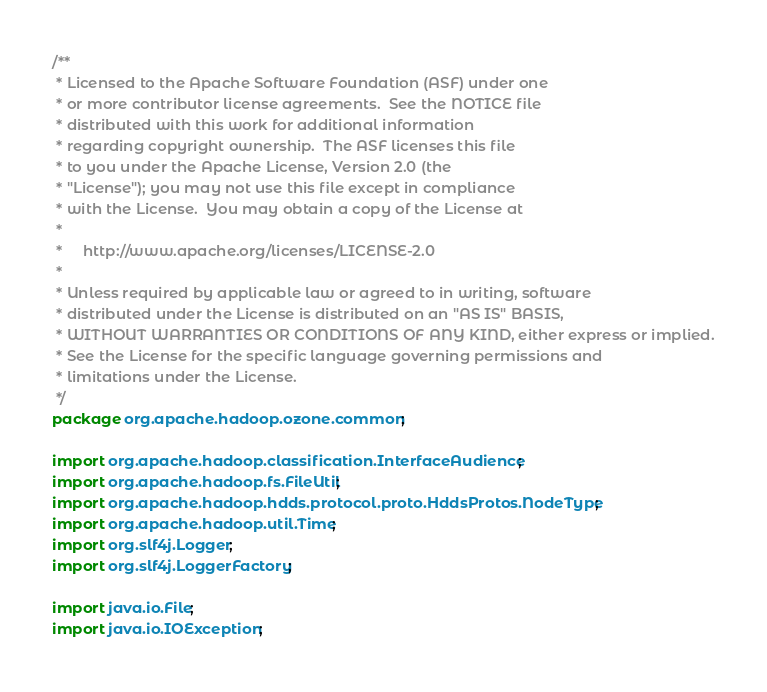<code> <loc_0><loc_0><loc_500><loc_500><_Java_>/**
 * Licensed to the Apache Software Foundation (ASF) under one
 * or more contributor license agreements.  See the NOTICE file
 * distributed with this work for additional information
 * regarding copyright ownership.  The ASF licenses this file
 * to you under the Apache License, Version 2.0 (the
 * "License"); you may not use this file except in compliance
 * with the License.  You may obtain a copy of the License at
 *
 *     http://www.apache.org/licenses/LICENSE-2.0
 *
 * Unless required by applicable law or agreed to in writing, software
 * distributed under the License is distributed on an "AS IS" BASIS,
 * WITHOUT WARRANTIES OR CONDITIONS OF ANY KIND, either express or implied.
 * See the License for the specific language governing permissions and
 * limitations under the License.
 */
package org.apache.hadoop.ozone.common;

import org.apache.hadoop.classification.InterfaceAudience;
import org.apache.hadoop.fs.FileUtil;
import org.apache.hadoop.hdds.protocol.proto.HddsProtos.NodeType;
import org.apache.hadoop.util.Time;
import org.slf4j.Logger;
import org.slf4j.LoggerFactory;

import java.io.File;
import java.io.IOException;</code> 